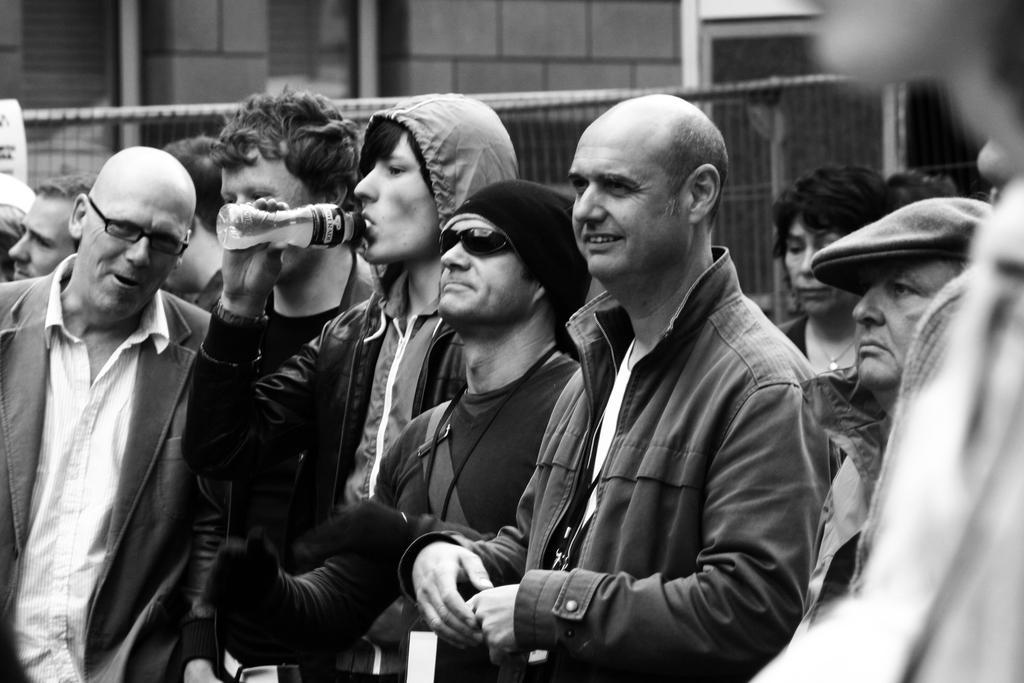Please provide a concise description of this image. This is a black and white picture. In the background we can see the wall, fence. In this picture we can see the group of people. We can see a man wearing a hoodie, he is holding a bottle and drinking. 